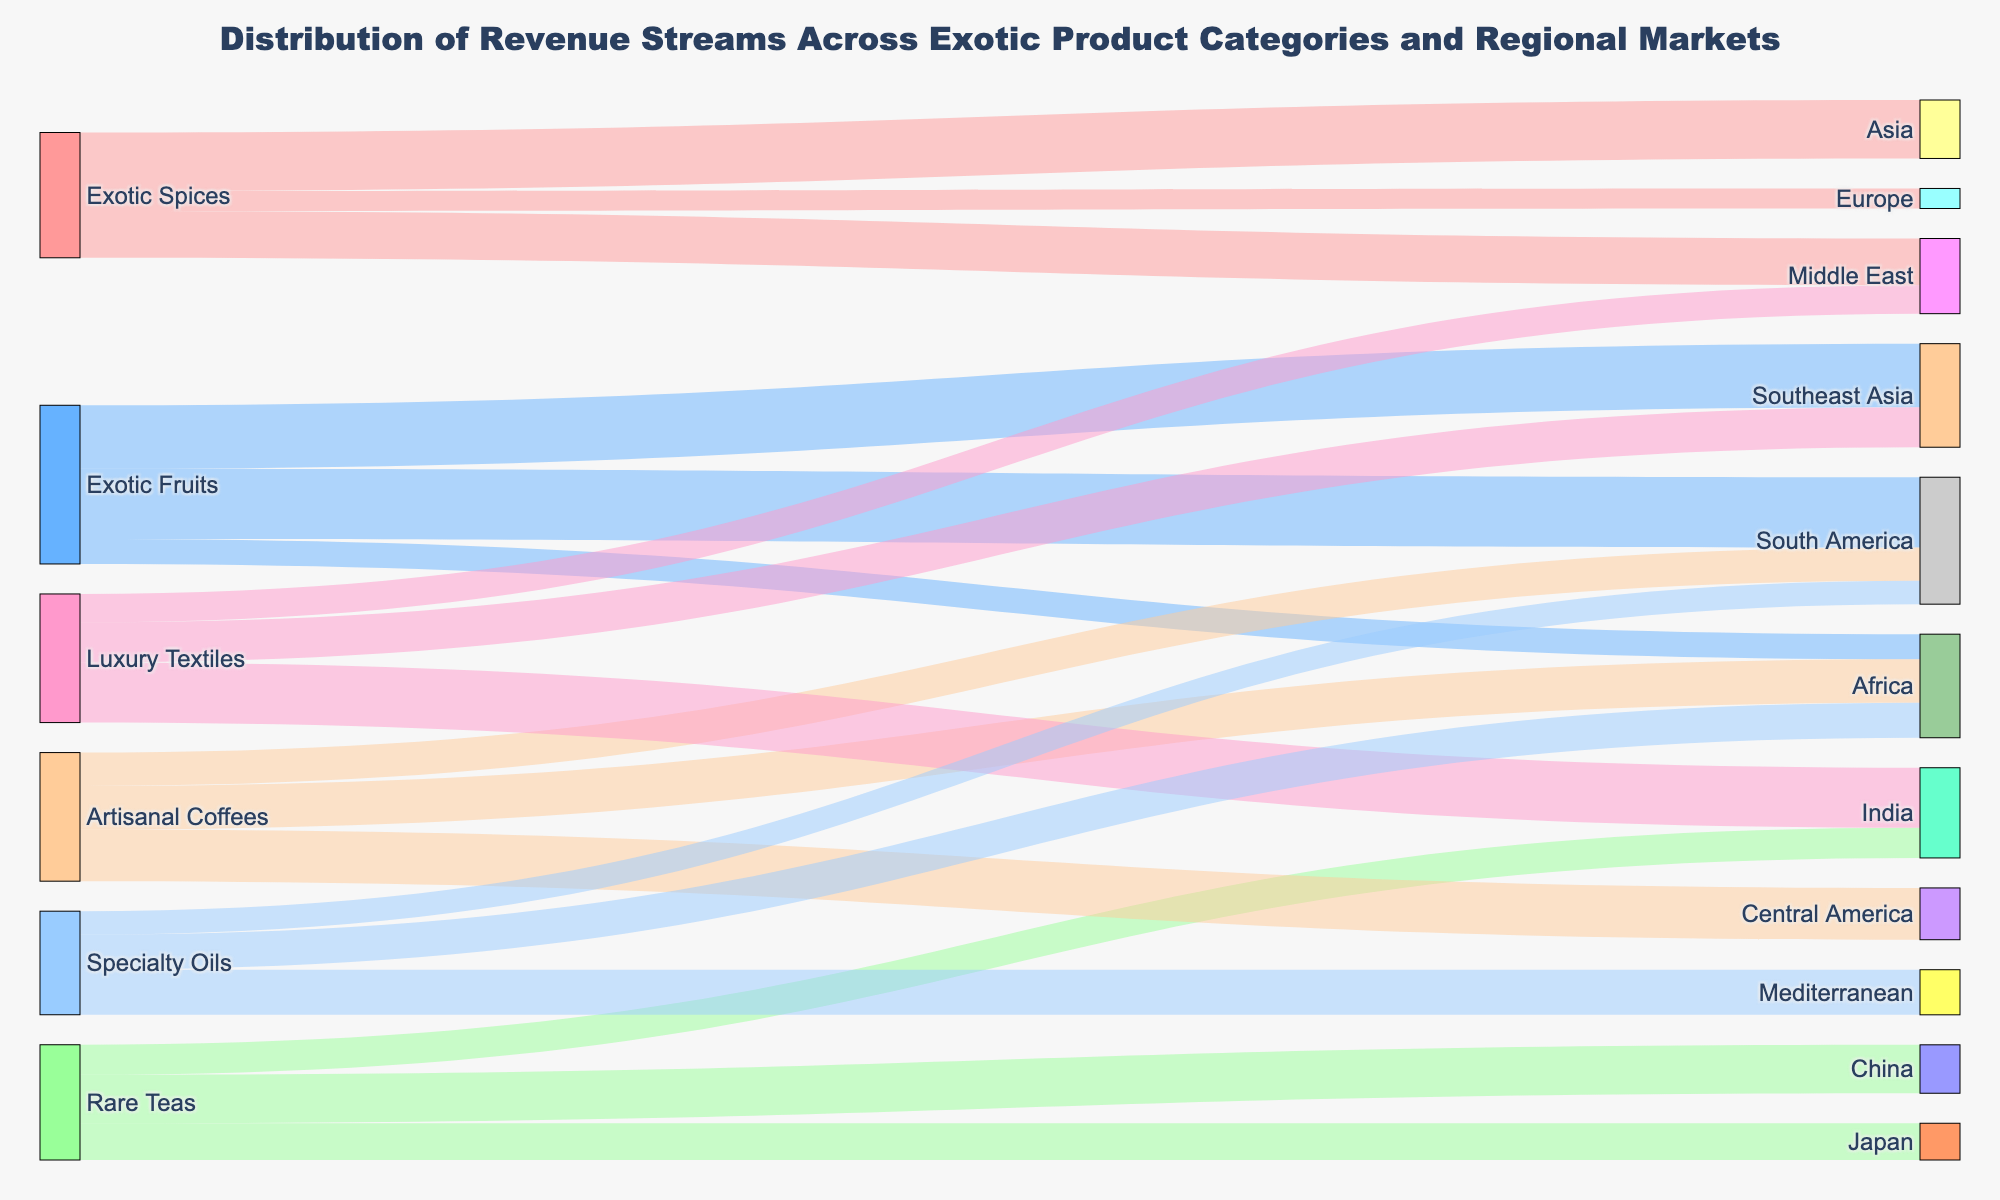What is the total revenue from Exotic Spices? To find the total revenue from Exotic Spices, sum the values for all the regional markets connected to Exotic Spices. The values are 3,500,000 (Asia) + 2,800,000 (Middle East) + 1,200,000 (Europe). Adding these numbers gives 7,500,000.
Answer: 7,500,000 Which product category generates the highest revenue in South America? The product categories connected to South America are Exotic Fruits and Specialty Oils, with values of 4,200,000 and 1,400,000, respectively. Exotic Fruits has the higher revenue.
Answer: Exotic Fruits How much more revenue does Exotic Fruits in Southeast Asia generate compared to Artisanal Coffees in Africa? Exotic Fruits in Southeast Asia generates 3,800,000, and Artisanal Coffees in Africa generates 2,600,000. To find the difference, subtract the smaller value from the larger one: 3,800,000 - 2,600,000 = 1,200,000.
Answer: 1,200,000 Which product category has the smallest revenue stream in Africa? The product categories connected to Africa are Exotic Fruits (1,500,000), Artisanal Coffees (2,600,000), and Specialty Oils (2,100,000). The smallest revenue stream is from Exotic Fruits.
Answer: Exotic Fruits What is the overall revenue from the Rare Teas product category? To find the overall revenue from Rare Teas, sum the values for all the regional markets connected to Rare Teas: 2,900,000 (China) + 2,200,000 (Japan) + 1,800,000 (India). Adding these numbers gives 6,900,000.
Answer: 6,900,000 Compare the revenue of Luxury Textiles in India to the total revenue of Specialty Oils. Luxury Textiles in India generates 3,600,000. The total revenue of Specialty Oils is the sum of 2,700,000 (Mediterranean), 2,100,000 (Africa), and 1,400,000 (South America), which totals 6,200,000. Comparing the two, Specialty Oils has a higher total revenue.
Answer: Specialty Oils What are the top three regional markets in terms of revenue generation for Exotic Fruits? The regional markets for Exotic Fruits are South America (4,200,000), Southeast Asia (3,800,000), and Africa (1,500,000). The top three markets in descending order of revenue are South America, Southeast Asia, and Africa.
Answer: South America, Southeast Asia, Africa Which product category has the most diverse regional market distribution? To determine the product category with the most diverse distribution, count the number of unique regional markets each product category is connected to. Exotic Spices is connected to 3 markets, Exotic Fruits to 3 markets, Rare Teas to 3 markets, Artisanal Coffees to 3 markets, Luxury Textiles to 3 markets, and Specialty Oils to 3 markets. All categories have an equal number of diverse distributions.
Answer: All categories equally What is the total revenue contribution from Southeast Asia across all product categories? Sum the values for Southeast Asia across all product categories: 3,800,000 (Exotic Fruits) + 2,400,000 (Luxury Textiles) = 6,200,000.
Answer: 6,200,000 